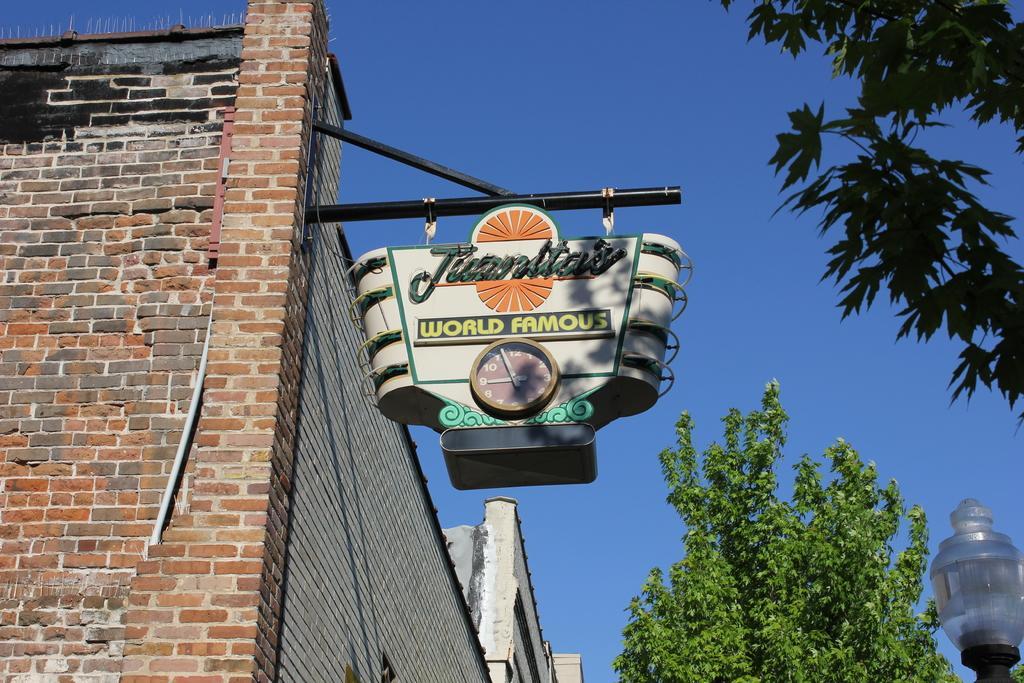How would you summarize this image in a sentence or two? In this picture we can see a name board with a clock on it, here we can see a building, trees, light and we can see sky in the background. 